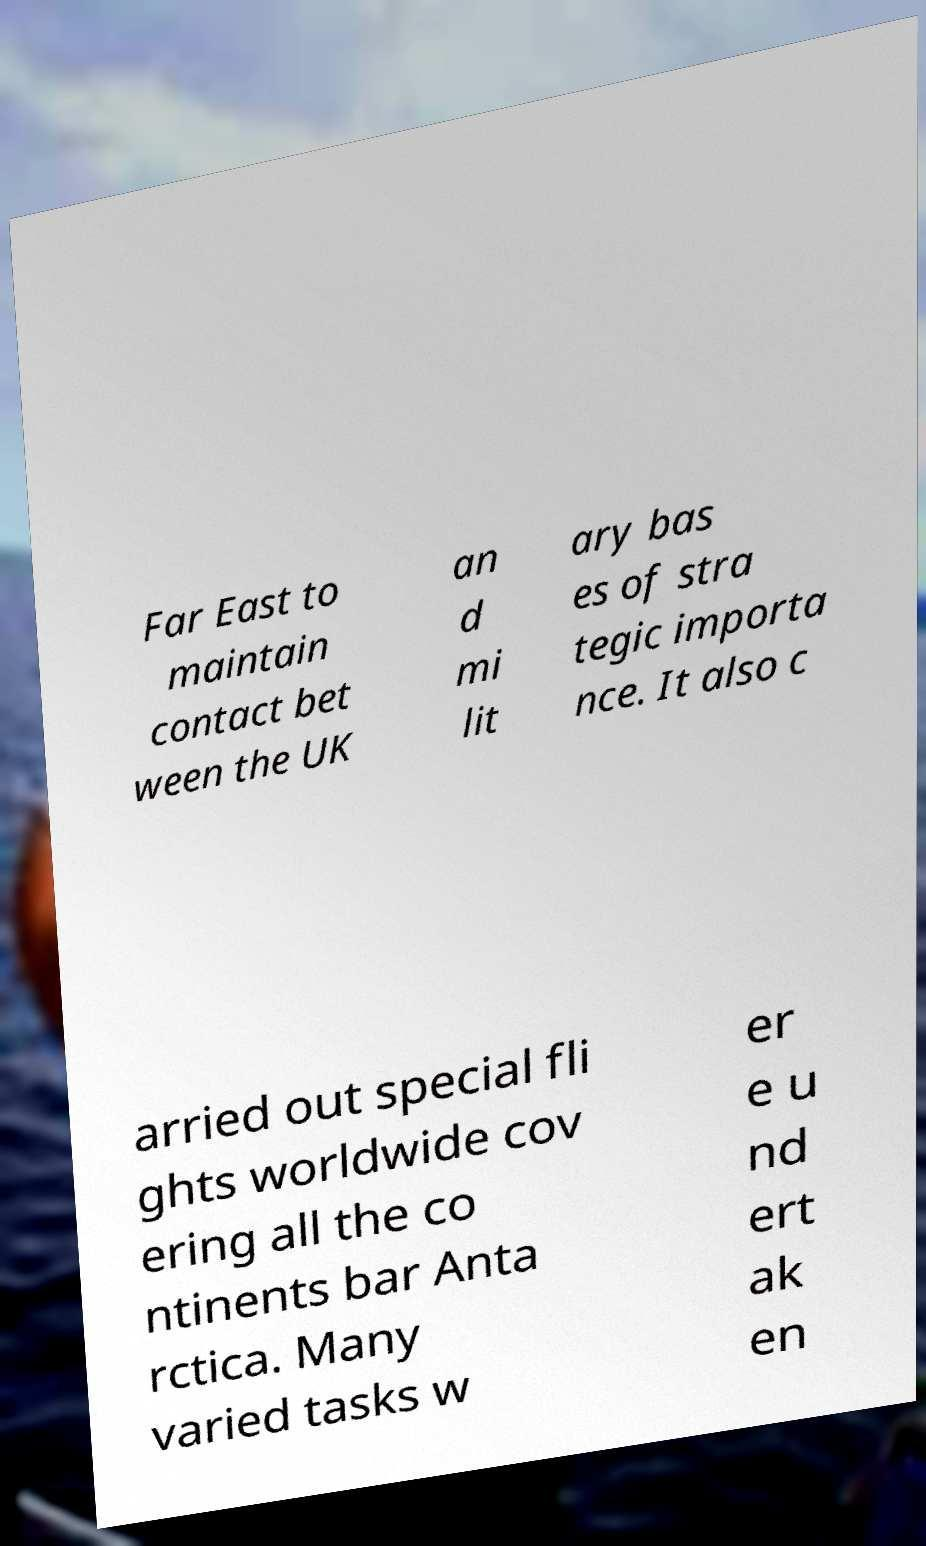Could you assist in decoding the text presented in this image and type it out clearly? Far East to maintain contact bet ween the UK an d mi lit ary bas es of stra tegic importa nce. It also c arried out special fli ghts worldwide cov ering all the co ntinents bar Anta rctica. Many varied tasks w er e u nd ert ak en 